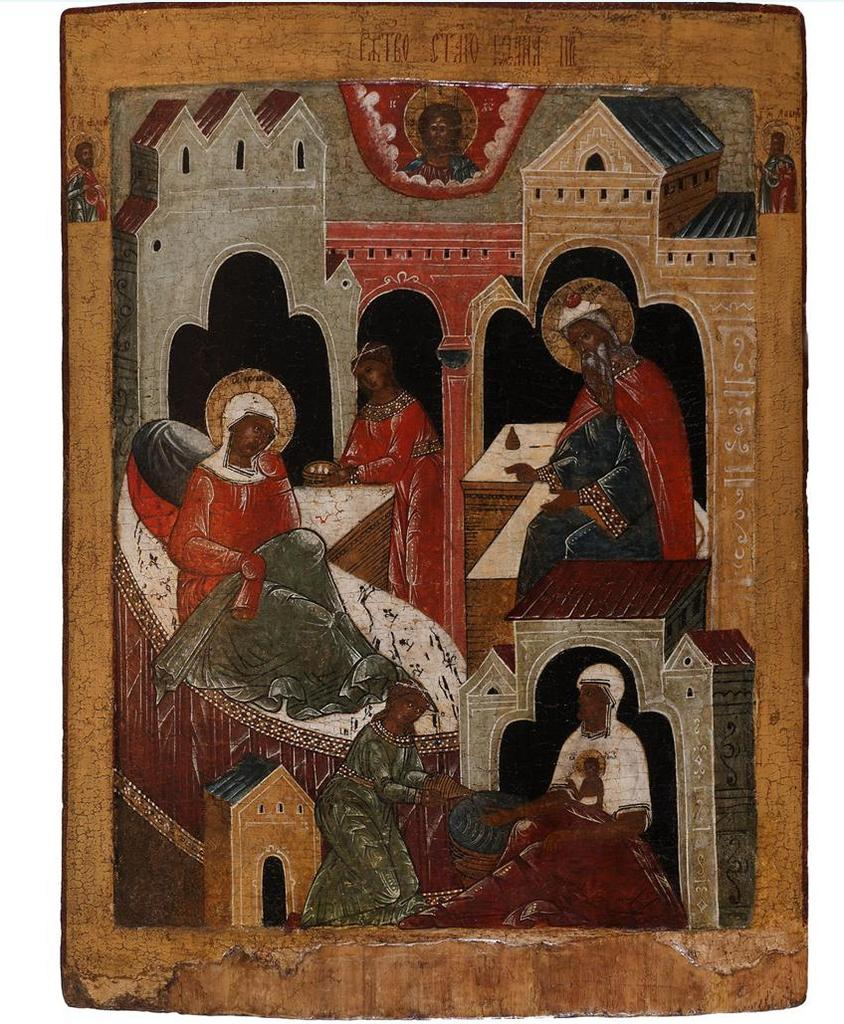What is on the wall in the image? There is a painting on the wall in the image. What can be seen in the painting? The painting contains people wearing clothes and depicts a building. How many dimes are scattered on the floor in the image? There are no dimes present in the image; it only features a painting on the wall. 